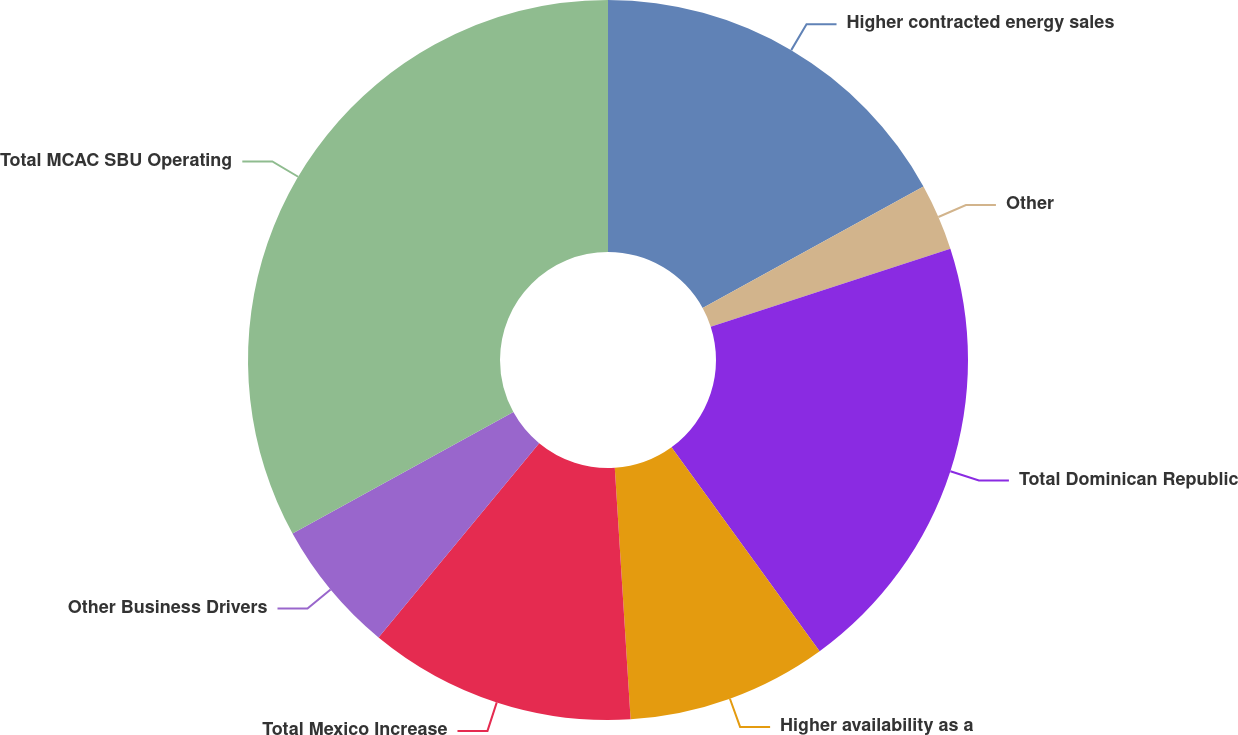<chart> <loc_0><loc_0><loc_500><loc_500><pie_chart><fcel>Higher contracted energy sales<fcel>Other<fcel>Total Dominican Republic<fcel>Higher availability as a<fcel>Total Mexico Increase<fcel>Other Business Drivers<fcel>Total MCAC SBU Operating<nl><fcel>17.0%<fcel>3.0%<fcel>20.0%<fcel>9.0%<fcel>12.0%<fcel>6.0%<fcel>33.0%<nl></chart> 